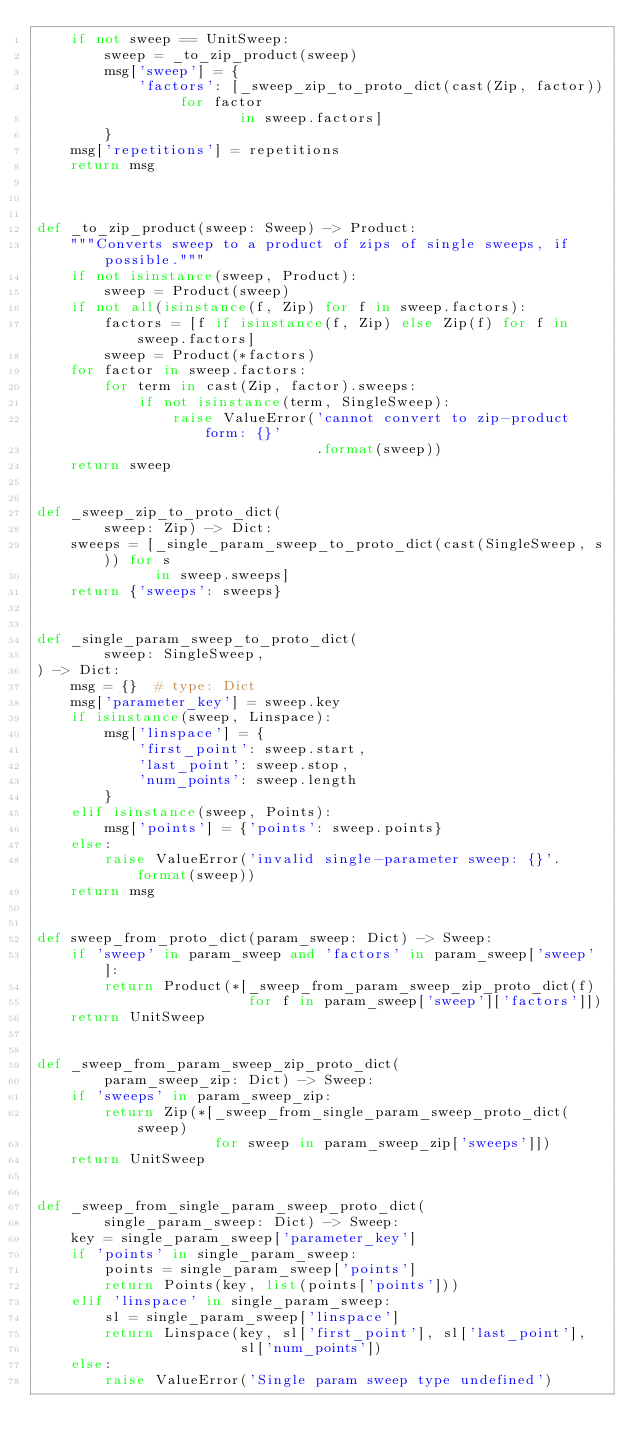<code> <loc_0><loc_0><loc_500><loc_500><_Python_>    if not sweep == UnitSweep:
        sweep = _to_zip_product(sweep)
        msg['sweep'] = {
            'factors': [_sweep_zip_to_proto_dict(cast(Zip, factor)) for factor
                        in sweep.factors]
        }
    msg['repetitions'] = repetitions
    return msg



def _to_zip_product(sweep: Sweep) -> Product:
    """Converts sweep to a product of zips of single sweeps, if possible."""
    if not isinstance(sweep, Product):
        sweep = Product(sweep)
    if not all(isinstance(f, Zip) for f in sweep.factors):
        factors = [f if isinstance(f, Zip) else Zip(f) for f in sweep.factors]
        sweep = Product(*factors)
    for factor in sweep.factors:
        for term in cast(Zip, factor).sweeps:
            if not isinstance(term, SingleSweep):
                raise ValueError('cannot convert to zip-product form: {}'
                                 .format(sweep))
    return sweep


def _sweep_zip_to_proto_dict(
        sweep: Zip) -> Dict:
    sweeps = [_single_param_sweep_to_proto_dict(cast(SingleSweep, s)) for s
              in sweep.sweeps]
    return {'sweeps': sweeps}


def _single_param_sweep_to_proto_dict(
        sweep: SingleSweep,
) -> Dict:
    msg = {}  # type: Dict
    msg['parameter_key'] = sweep.key
    if isinstance(sweep, Linspace):
        msg['linspace'] = {
            'first_point': sweep.start,
            'last_point': sweep.stop,
            'num_points': sweep.length
        }
    elif isinstance(sweep, Points):
        msg['points'] = {'points': sweep.points}
    else:
        raise ValueError('invalid single-parameter sweep: {}'.format(sweep))
    return msg


def sweep_from_proto_dict(param_sweep: Dict) -> Sweep:
    if 'sweep' in param_sweep and 'factors' in param_sweep['sweep']:
        return Product(*[_sweep_from_param_sweep_zip_proto_dict(f)
                         for f in param_sweep['sweep']['factors']])
    return UnitSweep


def _sweep_from_param_sweep_zip_proto_dict(
        param_sweep_zip: Dict) -> Sweep:
    if 'sweeps' in param_sweep_zip:
        return Zip(*[_sweep_from_single_param_sweep_proto_dict(sweep)
                     for sweep in param_sweep_zip['sweeps']])
    return UnitSweep


def _sweep_from_single_param_sweep_proto_dict(
        single_param_sweep: Dict) -> Sweep:
    key = single_param_sweep['parameter_key']
    if 'points' in single_param_sweep:
        points = single_param_sweep['points']
        return Points(key, list(points['points']))
    elif 'linspace' in single_param_sweep:
        sl = single_param_sweep['linspace']
        return Linspace(key, sl['first_point'], sl['last_point'],
                        sl['num_points'])
    else:
        raise ValueError('Single param sweep type undefined')
</code> 